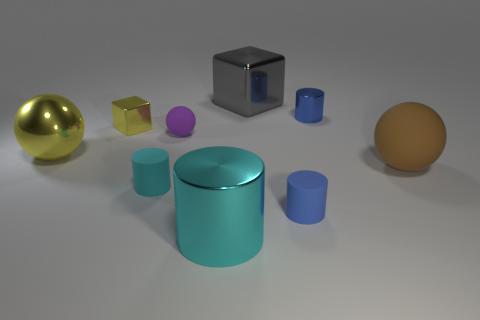There is a large gray thing that is on the left side of the matte thing to the right of the tiny blue shiny cylinder; what is its shape?
Give a very brief answer. Cube. How many other things are the same material as the tiny cyan thing?
Your answer should be very brief. 3. Are there more yellow metallic spheres than balls?
Provide a succinct answer. No. There is a cyan object on the right side of the tiny rubber cylinder that is left of the cyan cylinder that is on the right side of the small cyan cylinder; how big is it?
Make the answer very short. Large. Do the cyan shiny thing and the rubber ball left of the gray thing have the same size?
Provide a short and direct response. No. Is the number of blue metallic objects in front of the tiny cyan matte thing less than the number of big cyan cylinders?
Your response must be concise. Yes. What number of tiny shiny blocks are the same color as the metallic ball?
Offer a terse response. 1. Are there fewer brown rubber things than balls?
Make the answer very short. Yes. Do the small purple object and the brown ball have the same material?
Offer a terse response. Yes. How many other things are the same size as the yellow ball?
Ensure brevity in your answer.  3. 